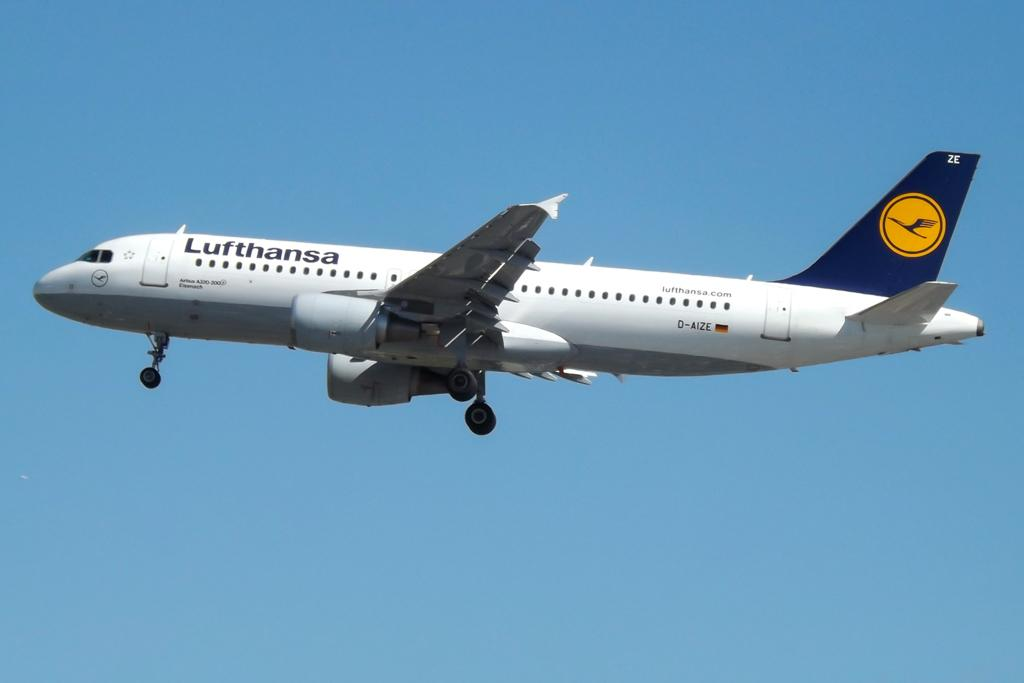<image>
Write a terse but informative summary of the picture. A jet in mid-flight has Lufthansa on the fuselage. 